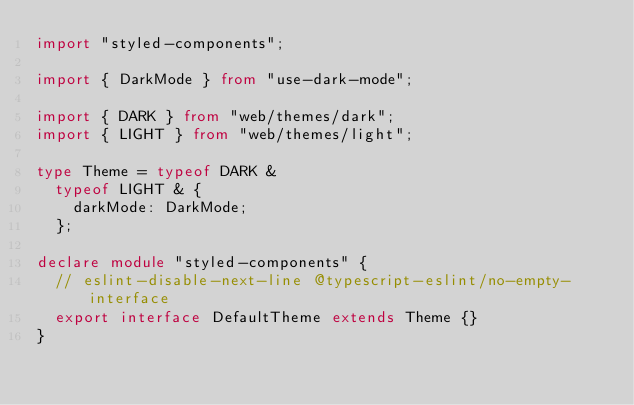<code> <loc_0><loc_0><loc_500><loc_500><_TypeScript_>import "styled-components";

import { DarkMode } from "use-dark-mode";

import { DARK } from "web/themes/dark";
import { LIGHT } from "web/themes/light";

type Theme = typeof DARK &
	typeof LIGHT & {
		darkMode: DarkMode;
	};

declare module "styled-components" {
	// eslint-disable-next-line @typescript-eslint/no-empty-interface
	export interface DefaultTheme extends Theme {}
}
</code> 